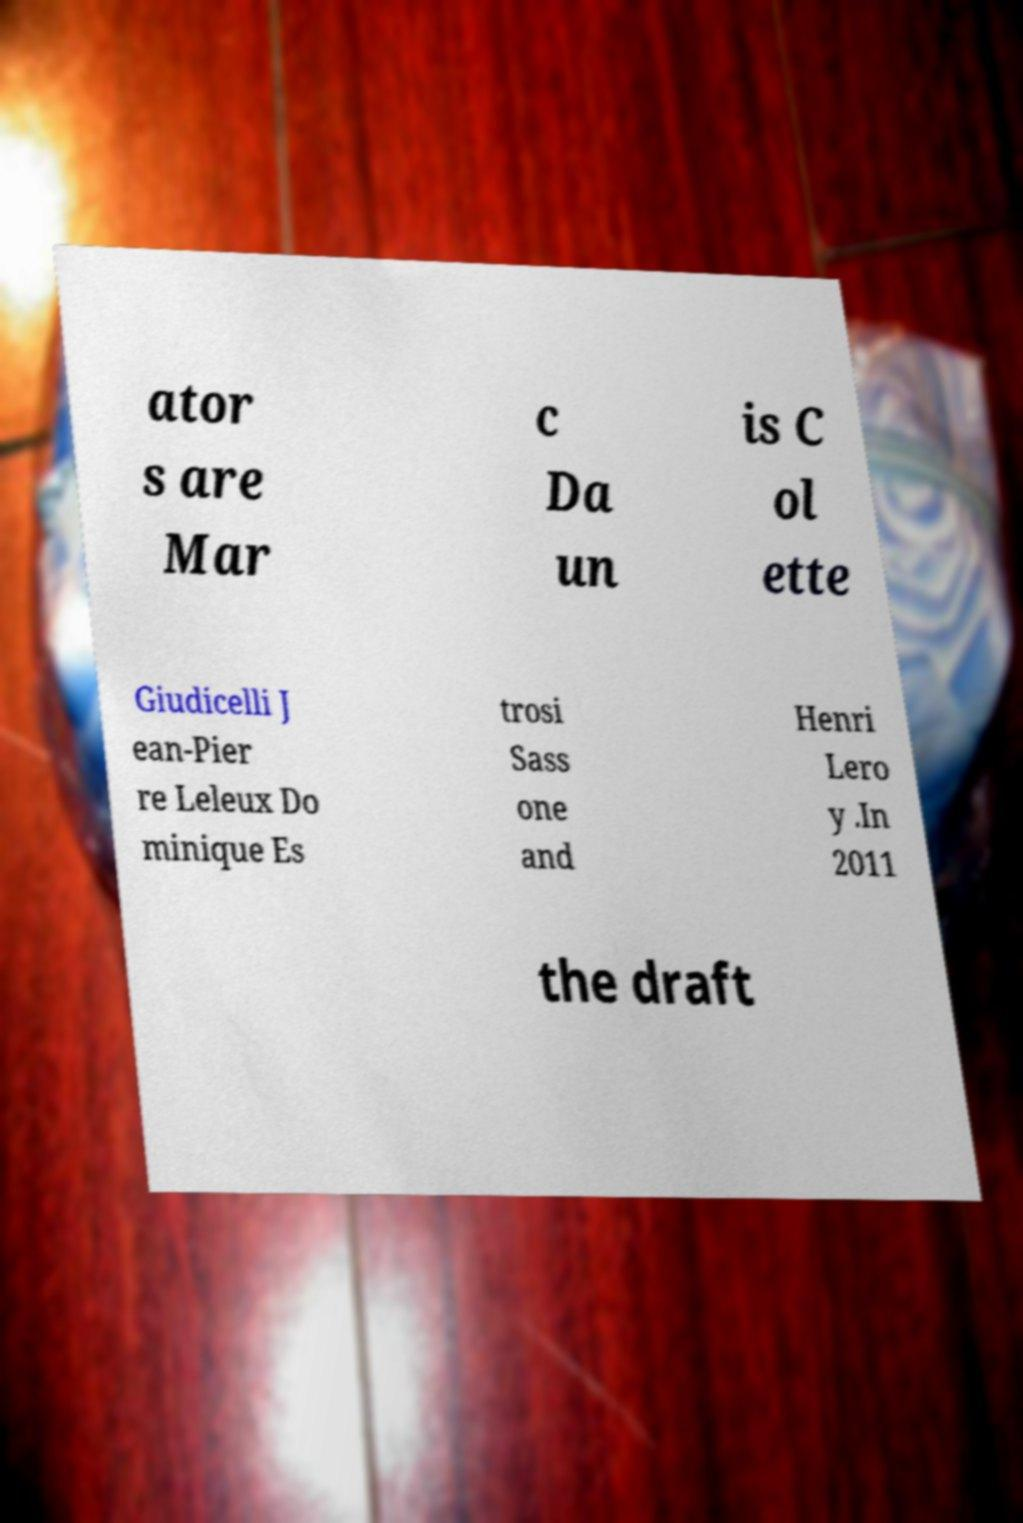Please identify and transcribe the text found in this image. ator s are Mar c Da un is C ol ette Giudicelli J ean-Pier re Leleux Do minique Es trosi Sass one and Henri Lero y .In 2011 the draft 